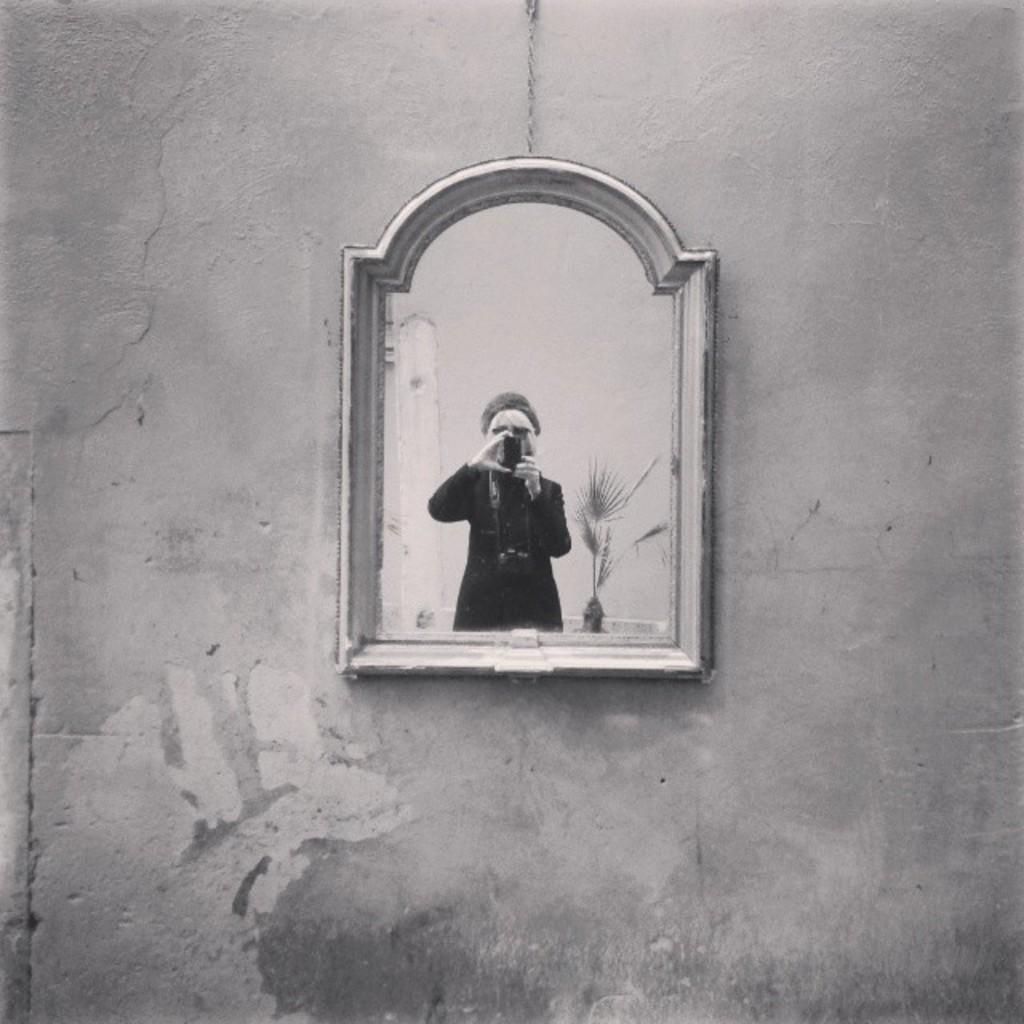Who is present in the image? There is a woman in the image. What is the woman holding in the image? The woman is holding an object. What other element can be seen in the image? There is a plant in the image. How can we determine that the image is a reflection? The image appears to be a reflection in a mirror. How many cents are visible on the calculator in the image? There is no calculator present in the image, so it is not possible to determine the number of cents visible. 